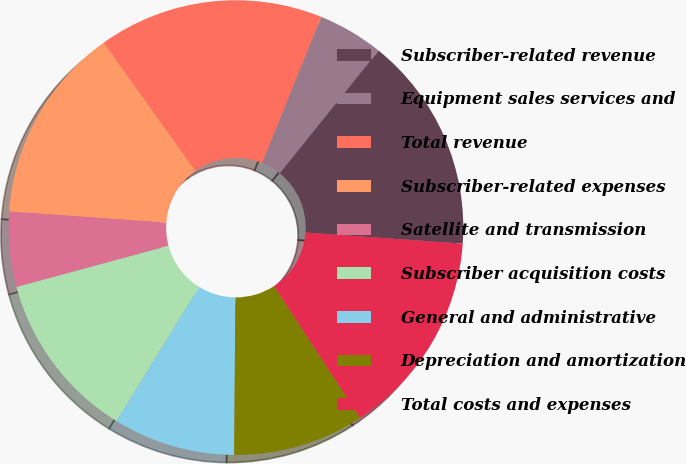Convert chart. <chart><loc_0><loc_0><loc_500><loc_500><pie_chart><fcel>Subscriber-related revenue<fcel>Equipment sales services and<fcel>Total revenue<fcel>Subscriber-related expenses<fcel>Satellite and transmission<fcel>Subscriber acquisition costs<fcel>General and administrative<fcel>Depreciation and amortization<fcel>Total costs and expenses<nl><fcel>15.33%<fcel>4.67%<fcel>16.0%<fcel>14.0%<fcel>5.33%<fcel>12.0%<fcel>8.67%<fcel>9.33%<fcel>14.67%<nl></chart> 